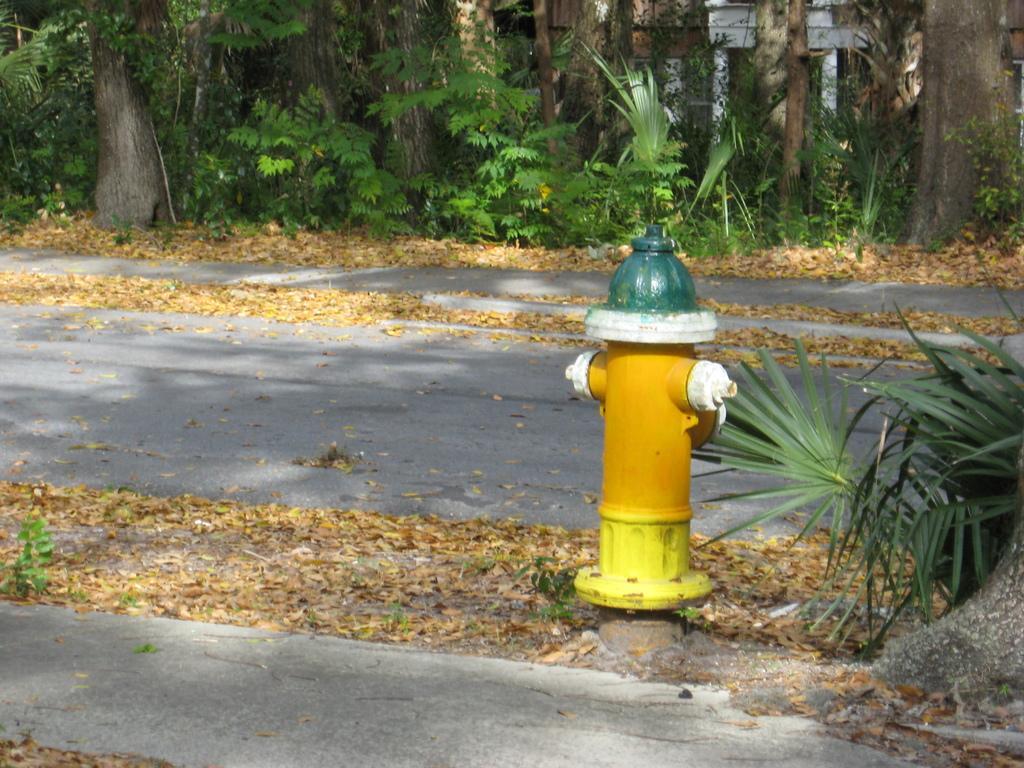In one or two sentences, can you explain what this image depicts? In this picture we can see a water hydrant in the front, at the bottom there are some leaves, in the background we can see trees and some plants. 